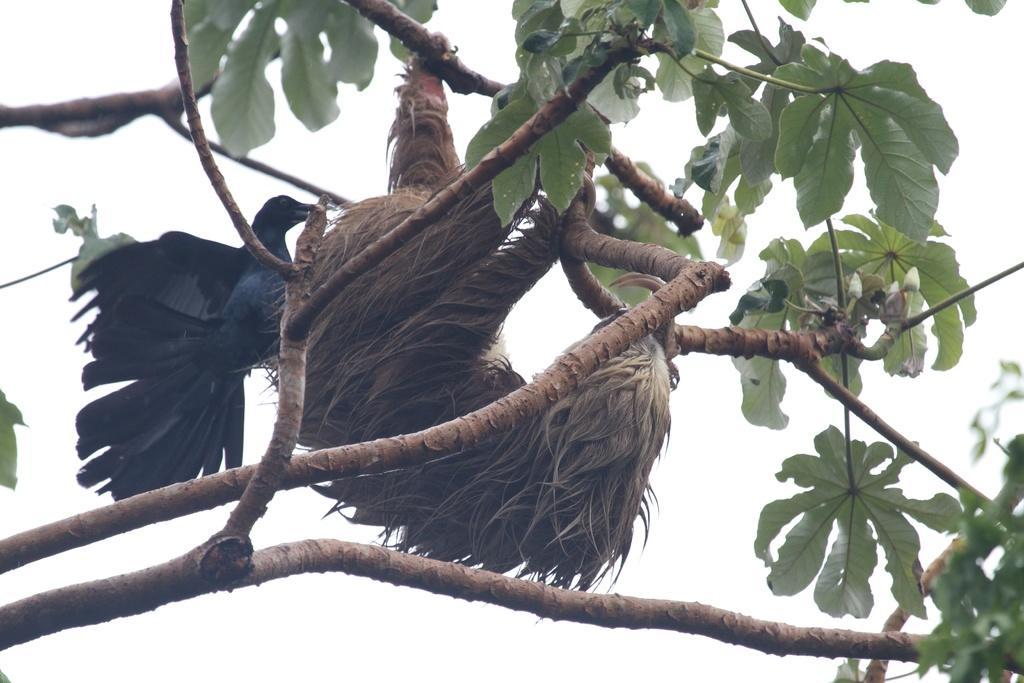In one or two sentences, can you explain what this image depicts? There is a black color bird and other animal on a tree. 